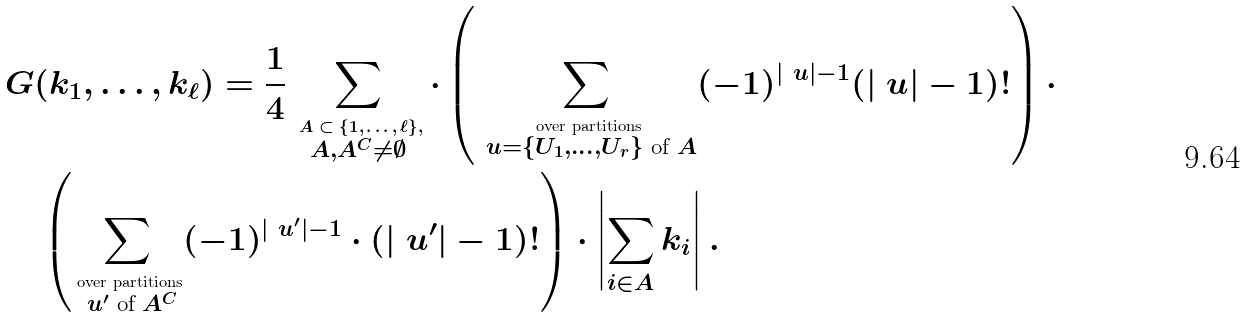Convert formula to latex. <formula><loc_0><loc_0><loc_500><loc_500>& G ( k _ { 1 } , \dots , k _ { \ell } ) = \frac { 1 } { 4 } \sum _ { \stackrel { \text { $A\subset\{1,\dots ,\ell\},$} } { A , A ^ { C } \neq \emptyset } } \cdot \left ( \sum _ { \stackrel { \text { over partitions} } { \ u = \{ U _ { 1 } , \dots , U _ { r } \} \text { of } A } } ( - 1 ) ^ { | \ u | - 1 } ( | \ u | - 1 ) ! \right ) \cdot \\ & \quad \left ( \sum _ { \stackrel { \text { over partitions} } { \ u ^ { \prime } \text { of } A ^ { C } } } ( - 1 ) ^ { | \ u ^ { \prime } | - 1 } \cdot ( | \ u ^ { \prime } | - 1 ) ! \right ) \cdot \left | \sum _ { i \in A } k _ { i } \right | .</formula> 